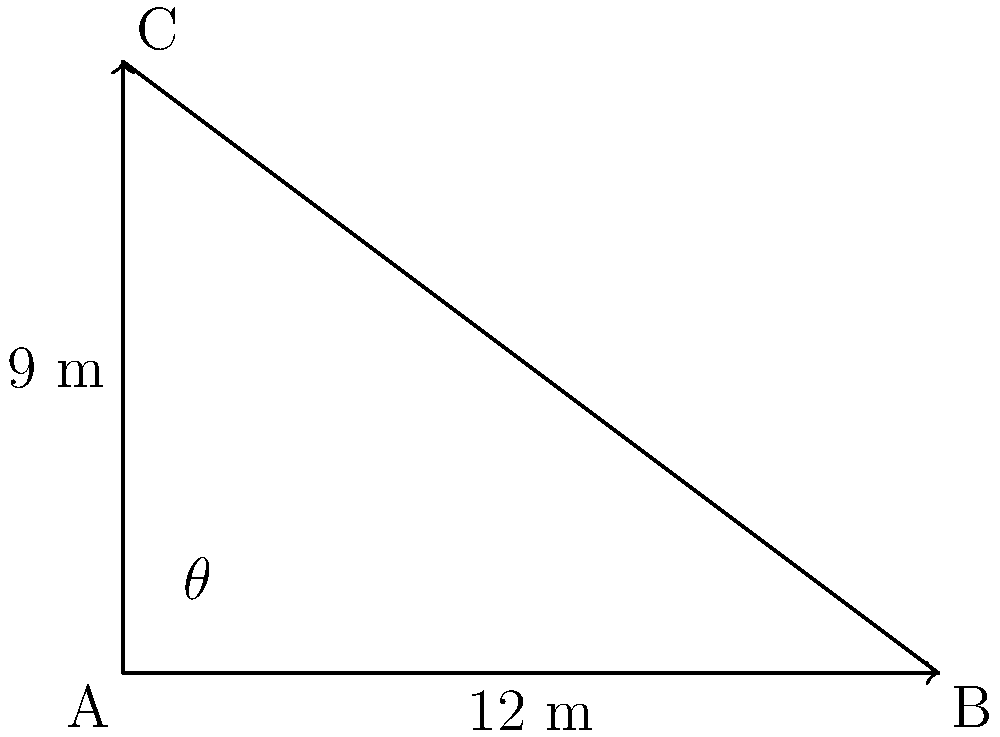While driving on BR-267, you encounter a steep section of road. To assess the incline, you measure a 12-meter horizontal distance along the road and find that the elevation increases by 9 meters over this distance. Using these measurements to form a right-angled triangle, what is the angle of inclination ($\theta$) of this road section? To solve this problem, we'll use trigonometry in a right-angled triangle:

1) We have a right-angled triangle where:
   - The adjacent side (horizontal distance) is 12 meters
   - The opposite side (elevation increase) is 9 meters
   - We need to find the angle $\theta$

2) The tangent of an angle in a right-angled triangle is the ratio of the opposite side to the adjacent side:

   $\tan(\theta) = \frac{\text{opposite}}{\text{adjacent}} = \frac{9}{12}$

3) To find $\theta$, we need to use the inverse tangent (arctan or $\tan^{-1}$):

   $\theta = \tan^{-1}(\frac{9}{12})$

4) Simplify the fraction:
   
   $\theta = \tan^{-1}(0.75)$

5) Using a calculator or trigonometric tables:

   $\theta \approx 36.87°$

6) Rounding to the nearest degree:

   $\theta \approx 37°$
Answer: $37°$ 